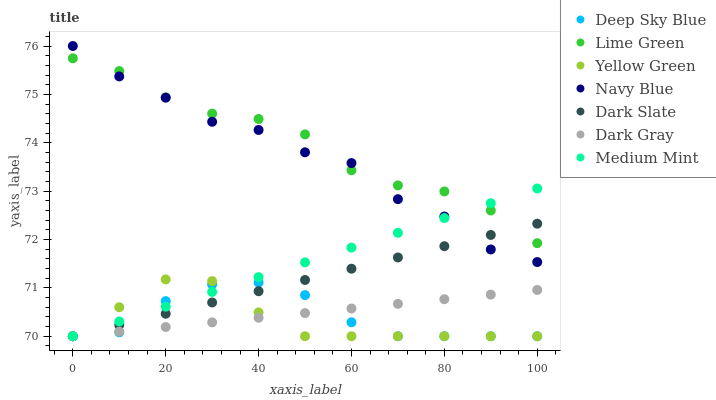Does Yellow Green have the minimum area under the curve?
Answer yes or no. Yes. Does Lime Green have the maximum area under the curve?
Answer yes or no. Yes. Does Navy Blue have the minimum area under the curve?
Answer yes or no. No. Does Navy Blue have the maximum area under the curve?
Answer yes or no. No. Is Dark Gray the smoothest?
Answer yes or no. Yes. Is Navy Blue the roughest?
Answer yes or no. Yes. Is Yellow Green the smoothest?
Answer yes or no. No. Is Yellow Green the roughest?
Answer yes or no. No. Does Medium Mint have the lowest value?
Answer yes or no. Yes. Does Navy Blue have the lowest value?
Answer yes or no. No. Does Navy Blue have the highest value?
Answer yes or no. Yes. Does Yellow Green have the highest value?
Answer yes or no. No. Is Deep Sky Blue less than Navy Blue?
Answer yes or no. Yes. Is Lime Green greater than Yellow Green?
Answer yes or no. Yes. Does Dark Gray intersect Yellow Green?
Answer yes or no. Yes. Is Dark Gray less than Yellow Green?
Answer yes or no. No. Is Dark Gray greater than Yellow Green?
Answer yes or no. No. Does Deep Sky Blue intersect Navy Blue?
Answer yes or no. No. 